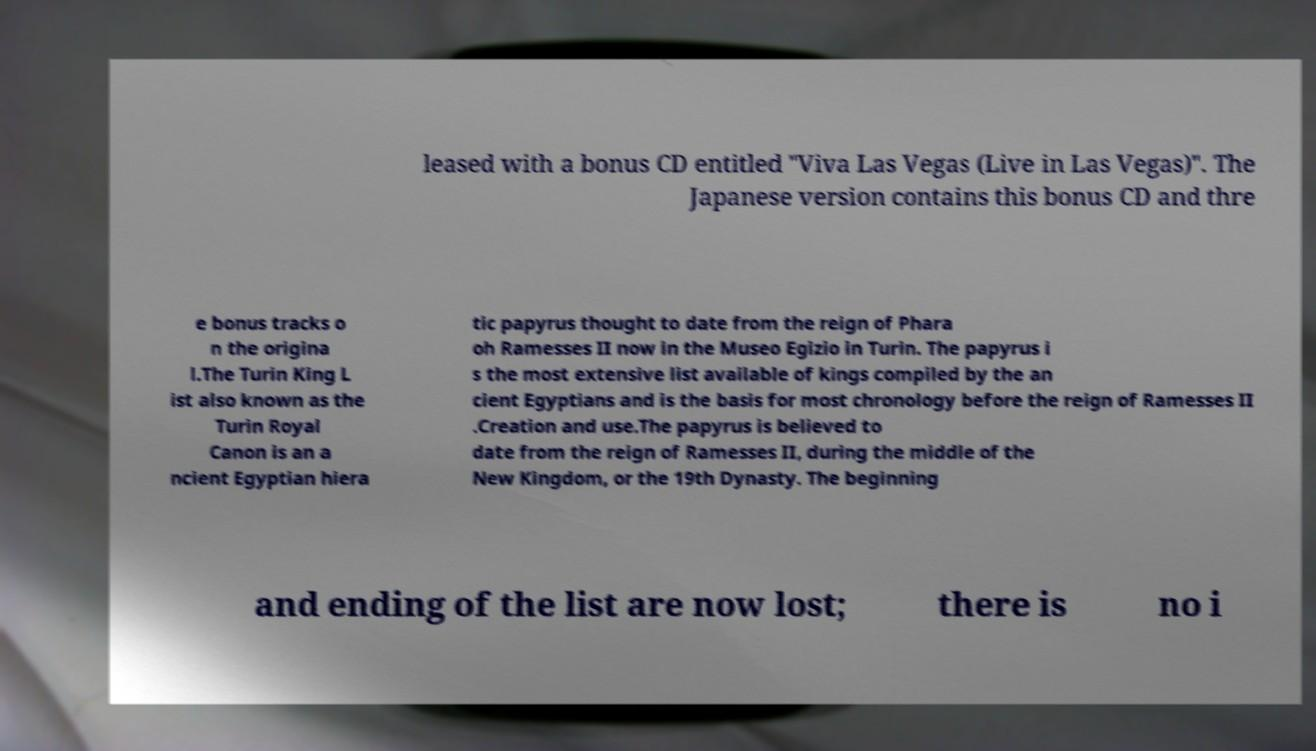Could you assist in decoding the text presented in this image and type it out clearly? leased with a bonus CD entitled "Viva Las Vegas (Live in Las Vegas)". The Japanese version contains this bonus CD and thre e bonus tracks o n the origina l.The Turin King L ist also known as the Turin Royal Canon is an a ncient Egyptian hiera tic papyrus thought to date from the reign of Phara oh Ramesses II now in the Museo Egizio in Turin. The papyrus i s the most extensive list available of kings compiled by the an cient Egyptians and is the basis for most chronology before the reign of Ramesses II .Creation and use.The papyrus is believed to date from the reign of Ramesses II, during the middle of the New Kingdom, or the 19th Dynasty. The beginning and ending of the list are now lost; there is no i 